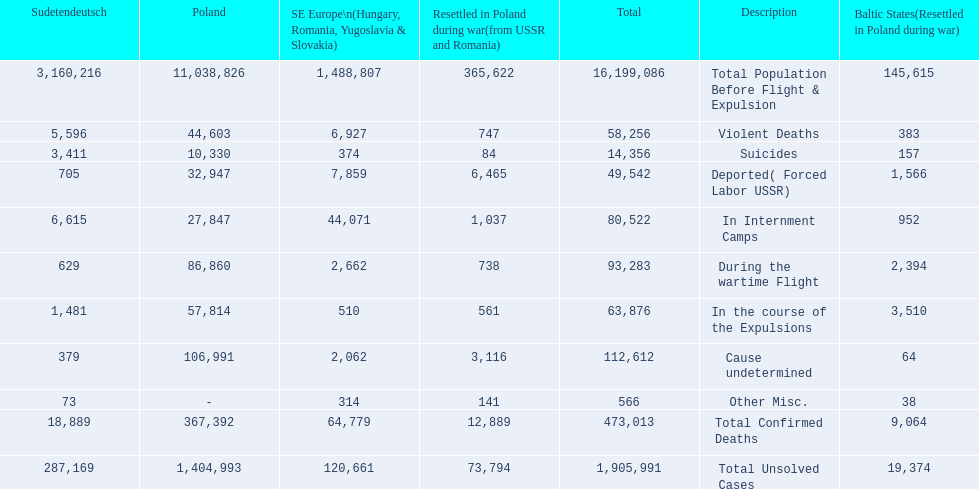Which country had the larger death tole? Poland. 